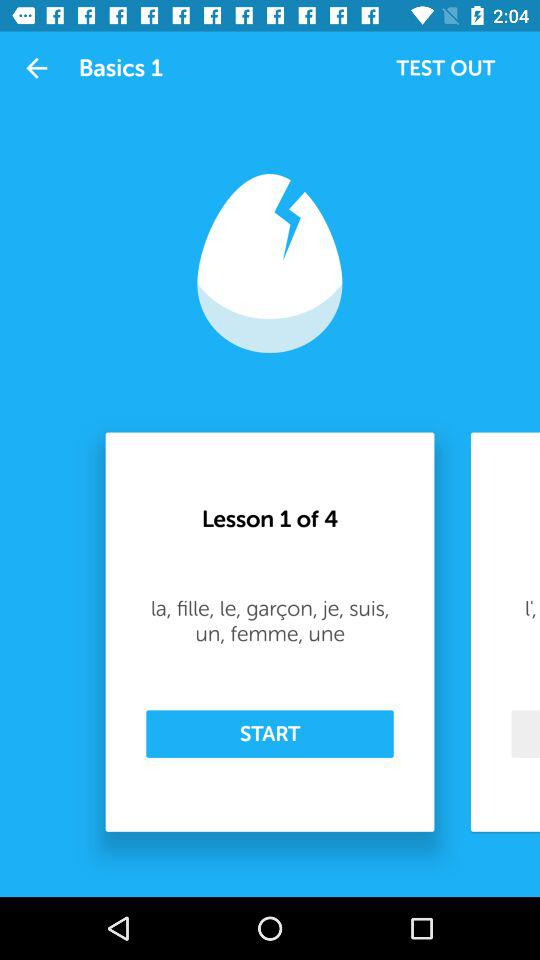At which lesson am I? You are at the first lesson. 